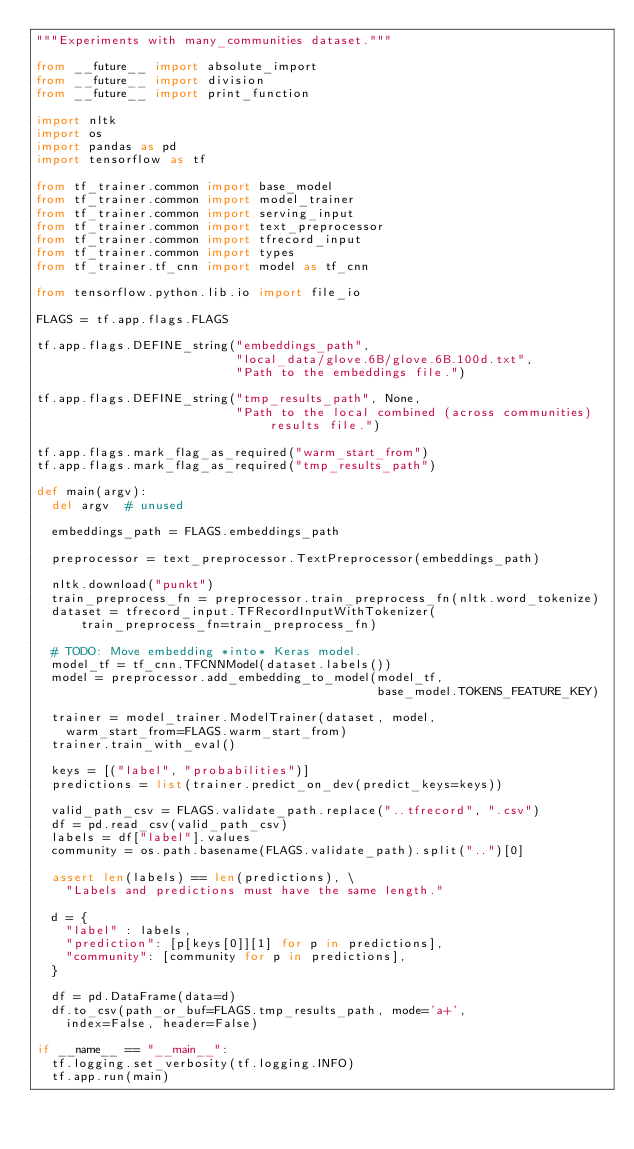Convert code to text. <code><loc_0><loc_0><loc_500><loc_500><_Python_>"""Experiments with many_communities dataset."""

from __future__ import absolute_import
from __future__ import division
from __future__ import print_function

import nltk
import os
import pandas as pd
import tensorflow as tf

from tf_trainer.common import base_model
from tf_trainer.common import model_trainer
from tf_trainer.common import serving_input
from tf_trainer.common import text_preprocessor
from tf_trainer.common import tfrecord_input
from tf_trainer.common import types
from tf_trainer.tf_cnn import model as tf_cnn

from tensorflow.python.lib.io import file_io

FLAGS = tf.app.flags.FLAGS

tf.app.flags.DEFINE_string("embeddings_path",
                           "local_data/glove.6B/glove.6B.100d.txt",
                           "Path to the embeddings file.")

tf.app.flags.DEFINE_string("tmp_results_path", None,
                           "Path to the local combined (across communities) results file.")

tf.app.flags.mark_flag_as_required("warm_start_from")
tf.app.flags.mark_flag_as_required("tmp_results_path")

def main(argv):
  del argv  # unused

  embeddings_path = FLAGS.embeddings_path

  preprocessor = text_preprocessor.TextPreprocessor(embeddings_path)

  nltk.download("punkt")
  train_preprocess_fn = preprocessor.train_preprocess_fn(nltk.word_tokenize)
  dataset = tfrecord_input.TFRecordInputWithTokenizer(
      train_preprocess_fn=train_preprocess_fn)

  # TODO: Move embedding *into* Keras model.
  model_tf = tf_cnn.TFCNNModel(dataset.labels())
  model = preprocessor.add_embedding_to_model(model_tf,
                                              base_model.TOKENS_FEATURE_KEY)

  trainer = model_trainer.ModelTrainer(dataset, model,
    warm_start_from=FLAGS.warm_start_from)
  trainer.train_with_eval()

  keys = [("label", "probabilities")]
  predictions = list(trainer.predict_on_dev(predict_keys=keys))

  valid_path_csv = FLAGS.validate_path.replace("..tfrecord", ".csv")
  df = pd.read_csv(valid_path_csv)
  labels = df["label"].values
  community = os.path.basename(FLAGS.validate_path).split("..")[0]

  assert len(labels) == len(predictions), \
    "Labels and predictions must have the same length."

  d = {
    "label" : labels,
    "prediction": [p[keys[0]][1] for p in predictions],
    "community": [community for p in predictions],
  }

  df = pd.DataFrame(data=d)
  df.to_csv(path_or_buf=FLAGS.tmp_results_path, mode='a+',
    index=False, header=False)

if __name__ == "__main__":
  tf.logging.set_verbosity(tf.logging.INFO)
  tf.app.run(main)
</code> 